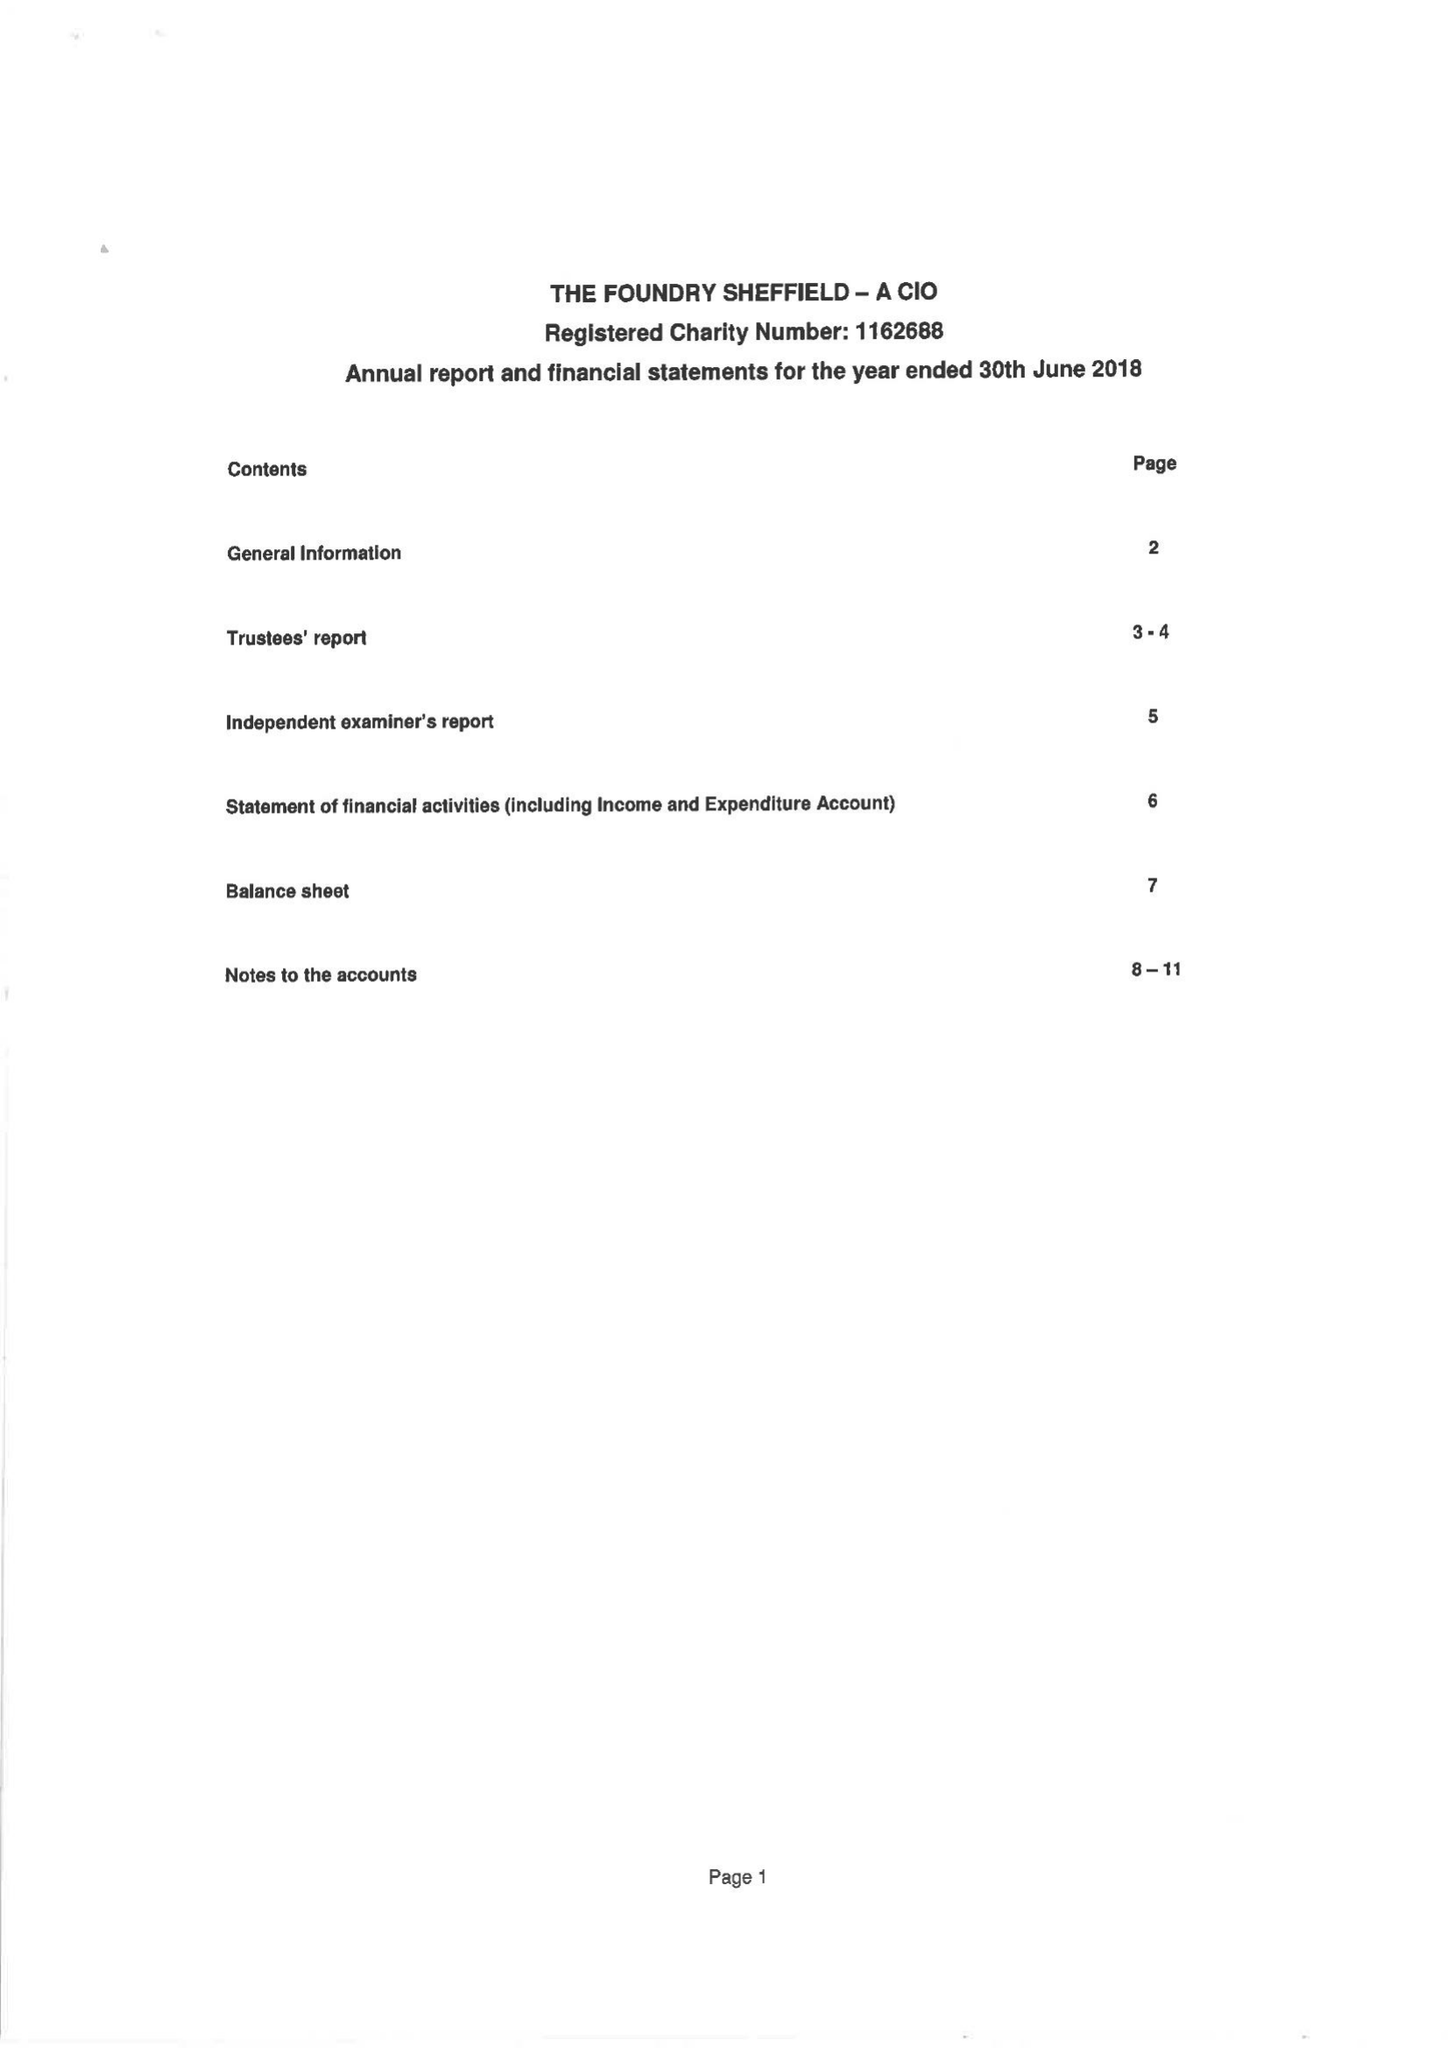What is the value for the report_date?
Answer the question using a single word or phrase. 2018-06-30 